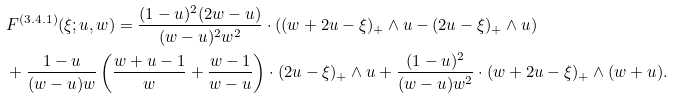<formula> <loc_0><loc_0><loc_500><loc_500>& F ^ { ( 3 . 4 . 1 ) } ( \xi ; u , w ) = \frac { ( 1 - u ) ^ { 2 } ( 2 w - u ) } { ( w - u ) ^ { 2 } w ^ { 2 } } \cdot \left ( ( w + 2 u - \xi ) _ { + } \wedge u - ( 2 u - \xi ) _ { + } \wedge u \right ) \\ & + \frac { 1 - u } { ( w - u ) w } \left ( \frac { w + u - 1 } { w } + \frac { w - 1 } { w - u } \right ) \cdot ( 2 u - \xi ) _ { + } \wedge u + \frac { ( 1 - u ) ^ { 2 } } { ( w - u ) w ^ { 2 } } \cdot ( w + 2 u - \xi ) _ { + } \wedge ( w + u ) .</formula> 